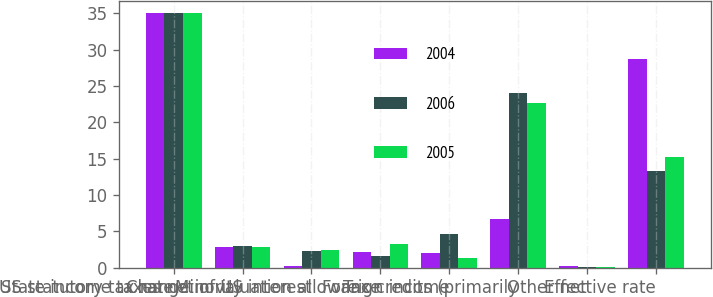Convert chart to OTSL. <chart><loc_0><loc_0><loc_500><loc_500><stacked_bar_chart><ecel><fcel>US statutory tax rate<fcel>State income taxes net of US<fcel>Minority interest<fcel>Change in valuation allowance<fcel>Foreign income<fcel>Tax credits (primarily<fcel>Other net<fcel>Effective rate<nl><fcel>2004<fcel>35<fcel>2.9<fcel>0.2<fcel>2.1<fcel>2<fcel>6.7<fcel>0.3<fcel>28.7<nl><fcel>2006<fcel>35<fcel>3<fcel>2.3<fcel>1.6<fcel>4.6<fcel>24.1<fcel>0.1<fcel>13.3<nl><fcel>2005<fcel>35<fcel>2.9<fcel>2.4<fcel>3.3<fcel>1.4<fcel>22.6<fcel>0.1<fcel>15.3<nl></chart> 